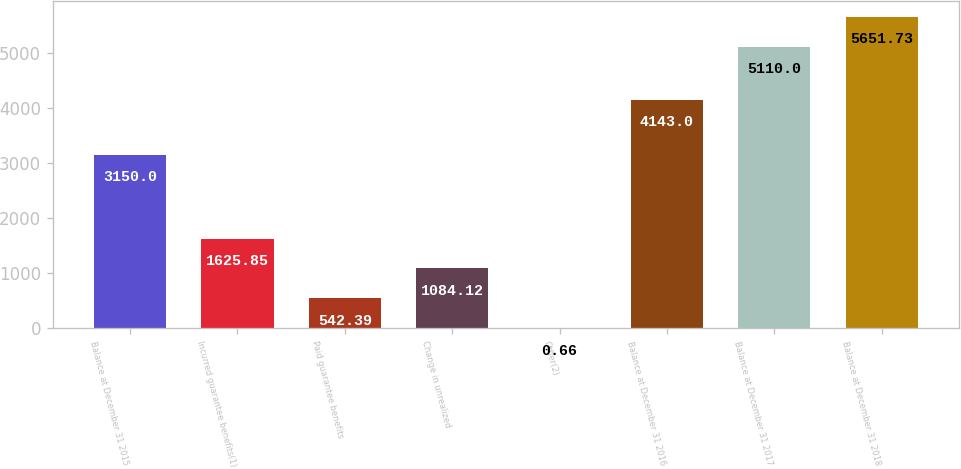Convert chart. <chart><loc_0><loc_0><loc_500><loc_500><bar_chart><fcel>Balance at December 31 2015<fcel>Incurred guarantee benefits(1)<fcel>Paid guarantee benefits<fcel>Change in unrealized<fcel>Other(2)<fcel>Balance at December 31 2016<fcel>Balance at December 31 2017<fcel>Balance at December 31 2018<nl><fcel>3150<fcel>1625.85<fcel>542.39<fcel>1084.12<fcel>0.66<fcel>4143<fcel>5110<fcel>5651.73<nl></chart> 